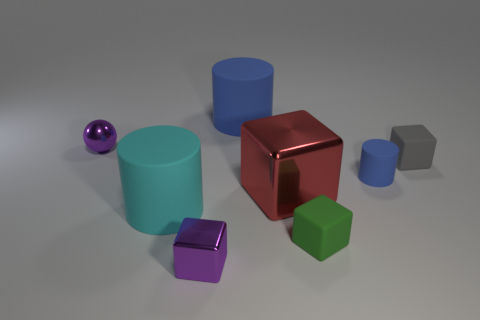The tiny thing that is the same color as the small ball is what shape?
Your answer should be very brief. Cube. What is the size of the cyan thing that is the same material as the large blue thing?
Ensure brevity in your answer.  Large. There is a thing that is the same color as the small metal ball; what size is it?
Ensure brevity in your answer.  Small. Is the color of the tiny ball the same as the tiny rubber cylinder?
Keep it short and to the point. No. Are there any tiny purple spheres to the right of the cylinder that is left of the small cube left of the large blue matte thing?
Your response must be concise. No. What number of gray rubber objects are the same size as the cyan matte cylinder?
Make the answer very short. 0. Do the rubber cylinder behind the small rubber cylinder and the purple object that is behind the purple block have the same size?
Give a very brief answer. No. There is a tiny object that is both on the right side of the big cyan matte cylinder and behind the tiny blue rubber cylinder; what shape is it?
Provide a short and direct response. Cube. Is there a cube that has the same color as the small cylinder?
Provide a short and direct response. No. Are any big metal objects visible?
Make the answer very short. Yes. 